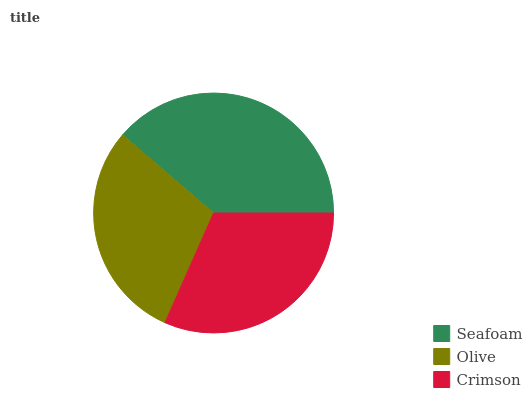Is Olive the minimum?
Answer yes or no. Yes. Is Seafoam the maximum?
Answer yes or no. Yes. Is Crimson the minimum?
Answer yes or no. No. Is Crimson the maximum?
Answer yes or no. No. Is Crimson greater than Olive?
Answer yes or no. Yes. Is Olive less than Crimson?
Answer yes or no. Yes. Is Olive greater than Crimson?
Answer yes or no. No. Is Crimson less than Olive?
Answer yes or no. No. Is Crimson the high median?
Answer yes or no. Yes. Is Crimson the low median?
Answer yes or no. Yes. Is Olive the high median?
Answer yes or no. No. Is Olive the low median?
Answer yes or no. No. 